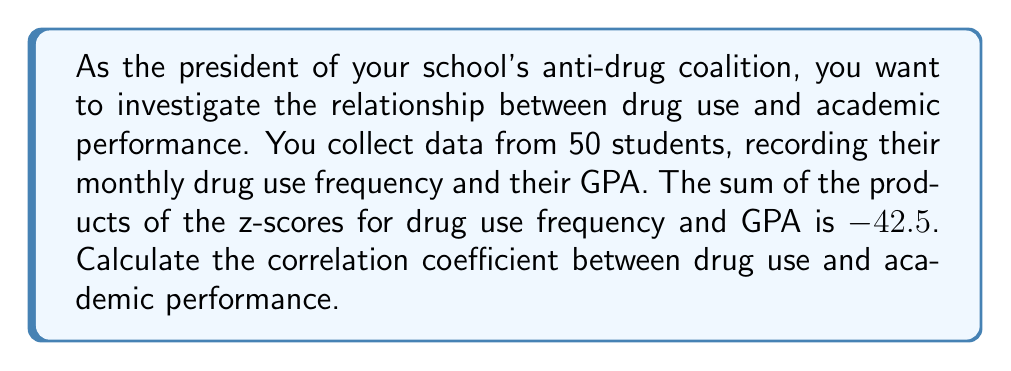Can you solve this math problem? To solve this problem, we'll use the formula for the correlation coefficient:

$$r = \frac{\sum z_x z_y}{n}$$

Where:
- $r$ is the correlation coefficient
- $\sum z_x z_y$ is the sum of the products of the z-scores
- $n$ is the number of data points

Given:
- $\sum z_x z_y = -42.5$
- $n = 50$

Step 1: Substitute the values into the formula:

$$r = \frac{-42.5}{50}$$

Step 2: Perform the division:

$$r = -0.85$$

The correlation coefficient ranges from -1 to 1, where:
- -1 indicates a perfect negative correlation
- 0 indicates no correlation
- 1 indicates a perfect positive correlation

In this case, -0.85 indicates a strong negative correlation between drug use and academic performance. This means that as drug use frequency increases, GPA tends to decrease, and vice versa.
Answer: $-0.85$ 